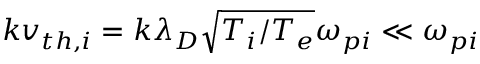Convert formula to latex. <formula><loc_0><loc_0><loc_500><loc_500>k v _ { t h , i } = k \lambda _ { D } \sqrt { T _ { i } / T _ { e } } \omega _ { p i } \ll \omega _ { p i }</formula> 